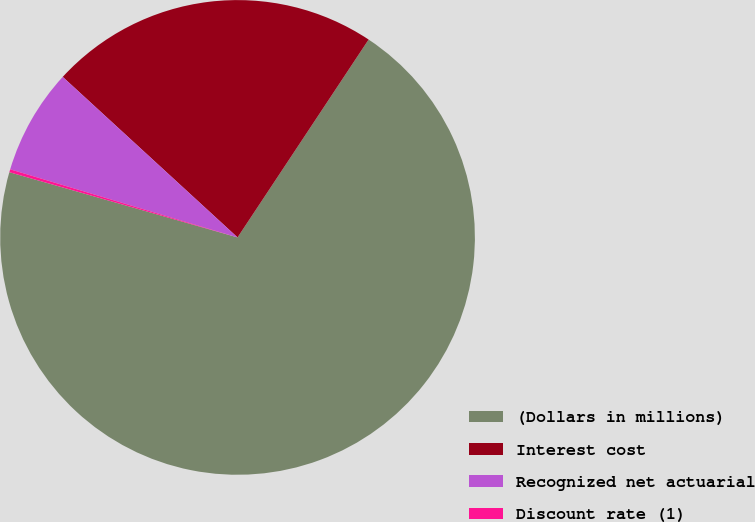<chart> <loc_0><loc_0><loc_500><loc_500><pie_chart><fcel>(Dollars in millions)<fcel>Interest cost<fcel>Recognized net actuarial<fcel>Discount rate (1)<nl><fcel>70.12%<fcel>22.49%<fcel>7.19%<fcel>0.2%<nl></chart> 